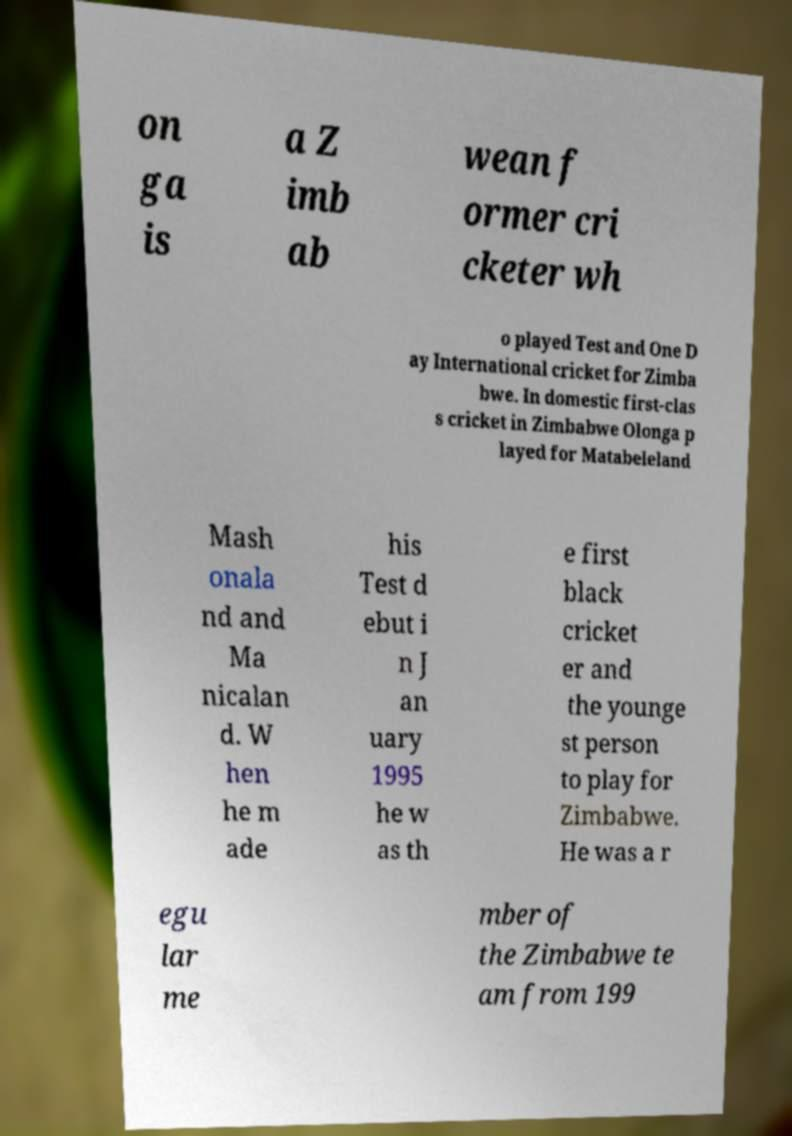Please read and relay the text visible in this image. What does it say? on ga is a Z imb ab wean f ormer cri cketer wh o played Test and One D ay International cricket for Zimba bwe. In domestic first-clas s cricket in Zimbabwe Olonga p layed for Matabeleland Mash onala nd and Ma nicalan d. W hen he m ade his Test d ebut i n J an uary 1995 he w as th e first black cricket er and the younge st person to play for Zimbabwe. He was a r egu lar me mber of the Zimbabwe te am from 199 